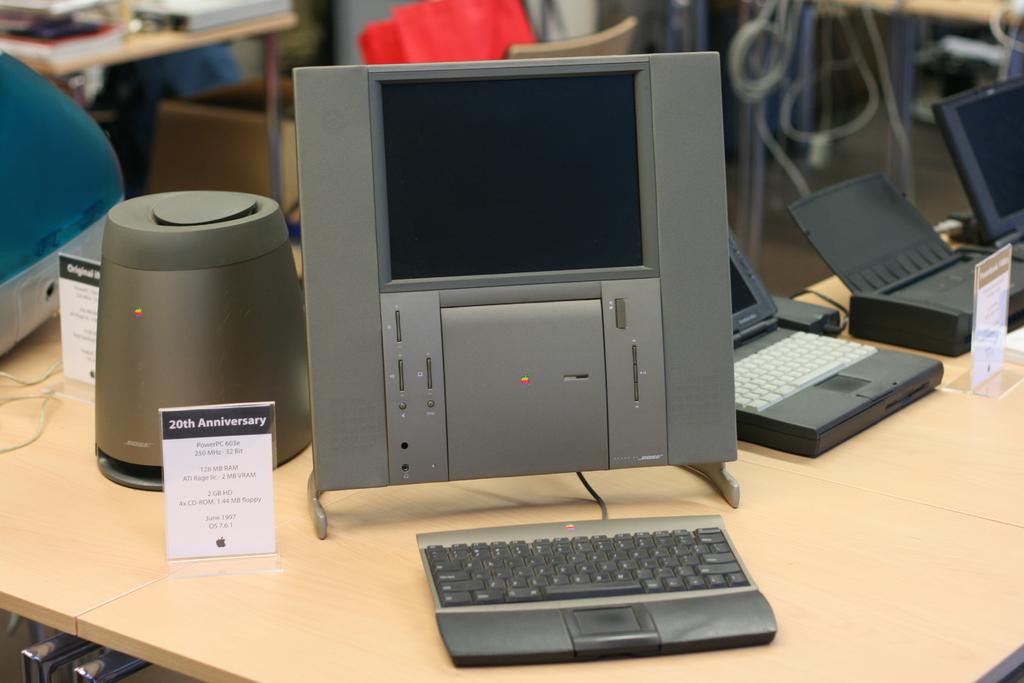How many anniversaries have there been according to the small sign?
Your answer should be very brief. 20. What brand is the speaker on the left?
Give a very brief answer. Bose. 